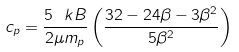<formula> <loc_0><loc_0><loc_500><loc_500>c _ { p } = \frac { 5 \ k B } { 2 \mu m _ { p } } \left ( \frac { 3 2 - 2 4 \beta - 3 \beta ^ { 2 } } { 5 \beta ^ { 2 } } \right )</formula> 